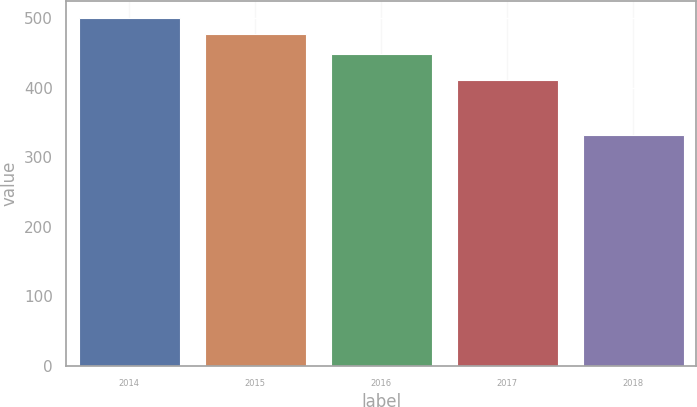Convert chart. <chart><loc_0><loc_0><loc_500><loc_500><bar_chart><fcel>2014<fcel>2015<fcel>2016<fcel>2017<fcel>2018<nl><fcel>500<fcel>478<fcel>449<fcel>411<fcel>332<nl></chart> 